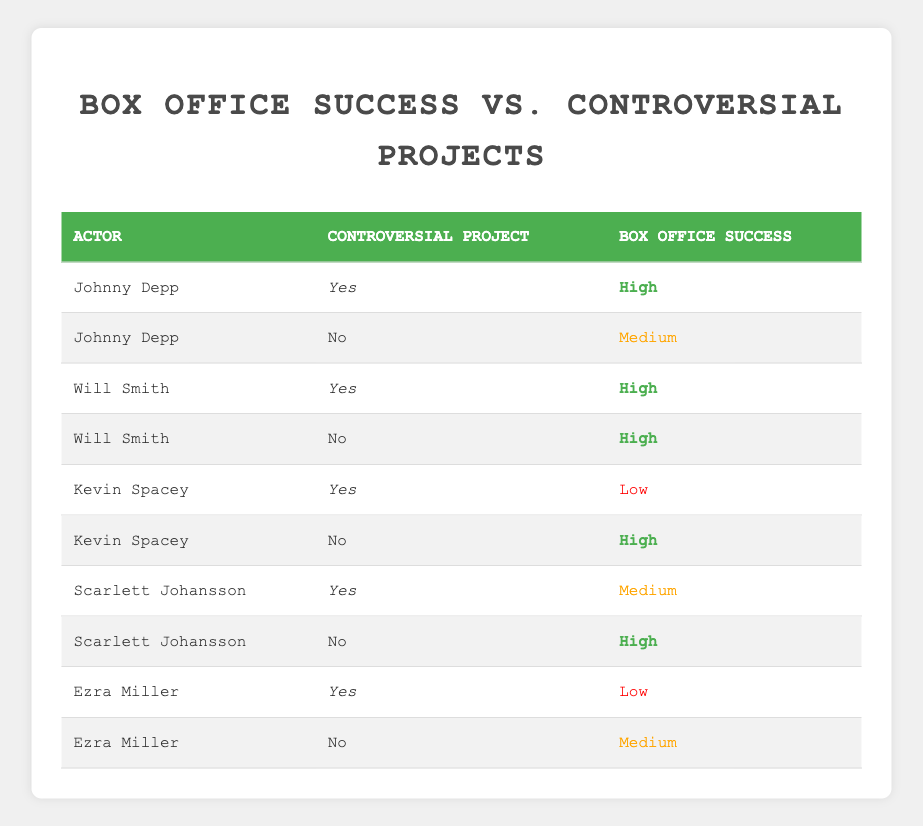What is the box office success of Johnny Depp in a controversial project? Johnny Depp's row shows that his box office success in a controversial project is categorized as "High." This can be confirmed directly from the table where he has a "Yes" under Controversial Project and "High" under Box Office Success.
Answer: High How many actors had a high box office success without any controversial projects? By analyzing the "No" under Controversial Project, we can see that Will Smith, Kevin Spacey, and Scarlett Johansson all had "High" box office success. In total, there are three actors meeting this criteria.
Answer: 3 Is it true that Ezra Miller had a low box office success in a controversial project? Referring to the row for Ezra Miller with "Yes" under Controversial Project, the box office success is listed as "Low." This means the statement is true.
Answer: Yes What is the box office success of Scarlett Johansson in non-controversial projects? The table indicates that Scarlett Johansson has "High" box office success when she is not involved in controversial projects. This can be found in the row where the Controversial Project is "No."
Answer: High Which actor experienced a low box office success due to controversial projects? Looking through the table, Kevin Spacey and Ezra Miller both had "Low" box office success in controversial projects. However, Kevin Spacey has "High" success in his non-controversial projects, which means only Ezra Miller fits solely in the low success category.
Answer: Ezra Miller 